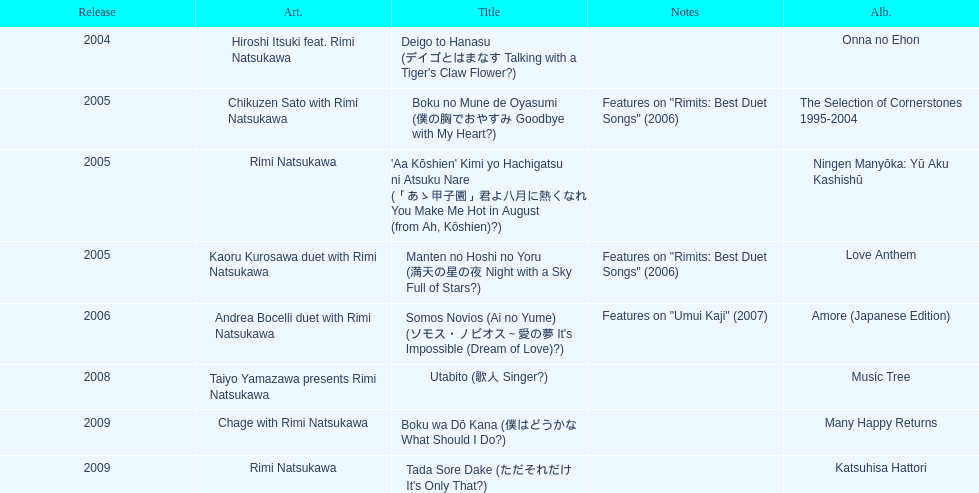What song was this artist on after utabito? Boku wa Dō Kana. 